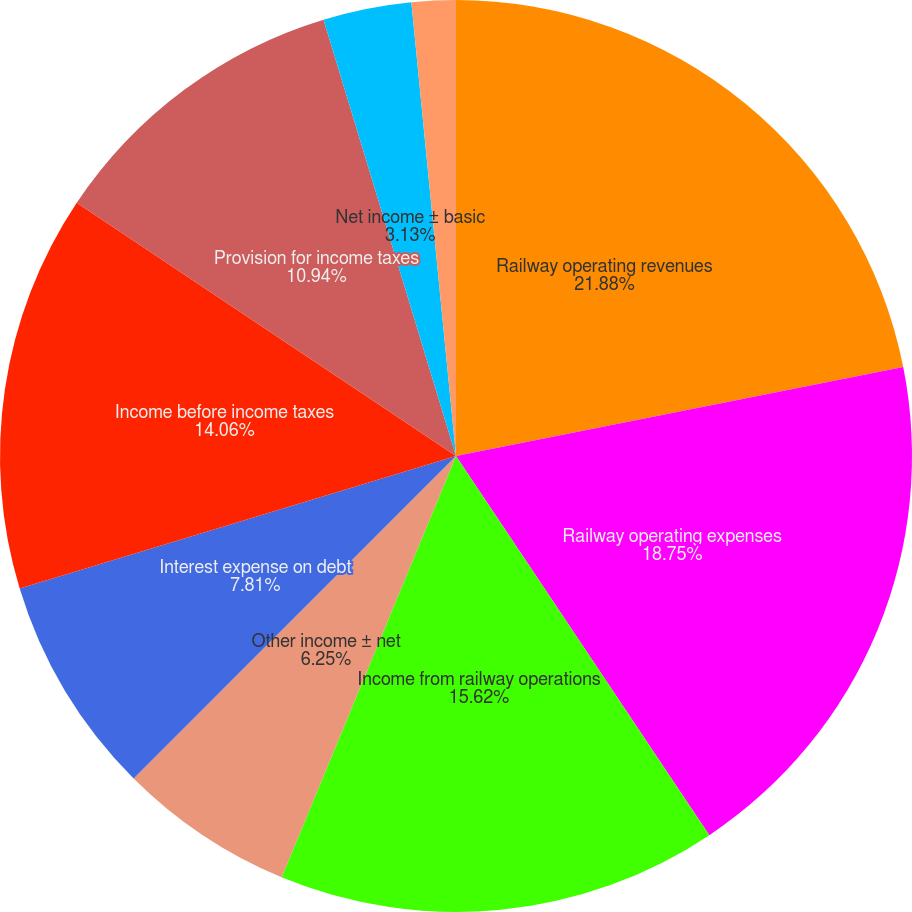<chart> <loc_0><loc_0><loc_500><loc_500><pie_chart><fcel>Railway operating revenues<fcel>Railway operating expenses<fcel>Income from railway operations<fcel>Other income ± net<fcel>Interest expense on debt<fcel>Income before income taxes<fcel>Provision for income taxes<fcel>Net income ± basic<fcel>± diluted<fcel>Dividends<nl><fcel>21.87%<fcel>18.75%<fcel>15.62%<fcel>6.25%<fcel>7.81%<fcel>14.06%<fcel>10.94%<fcel>3.13%<fcel>1.56%<fcel>0.0%<nl></chart> 